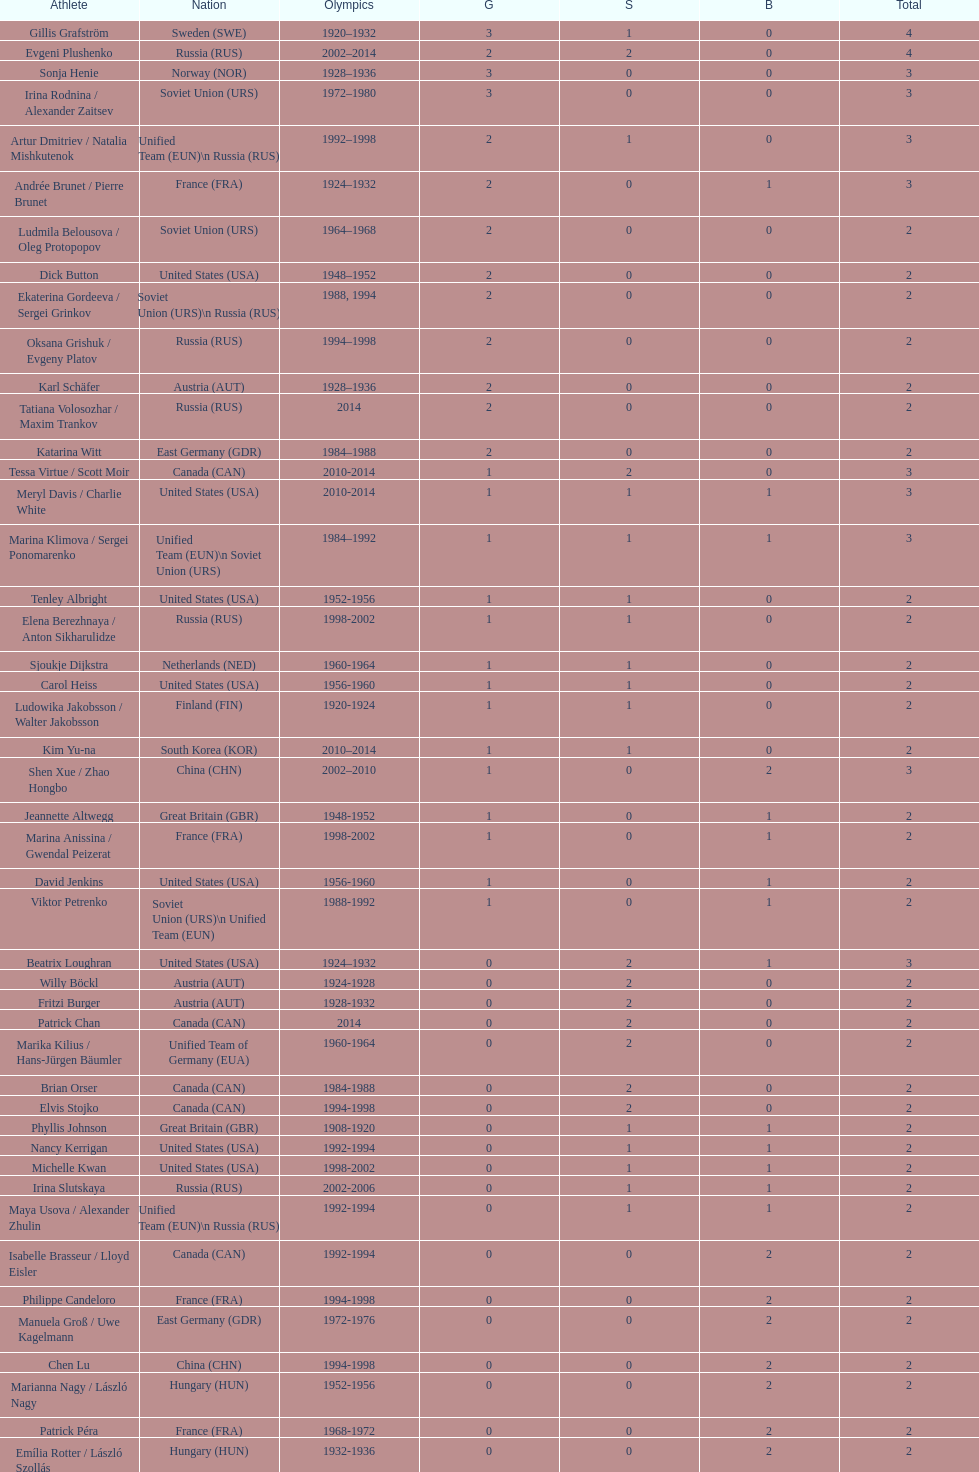In olympic figure skating, which nation first secured three gold medals? Sweden. 